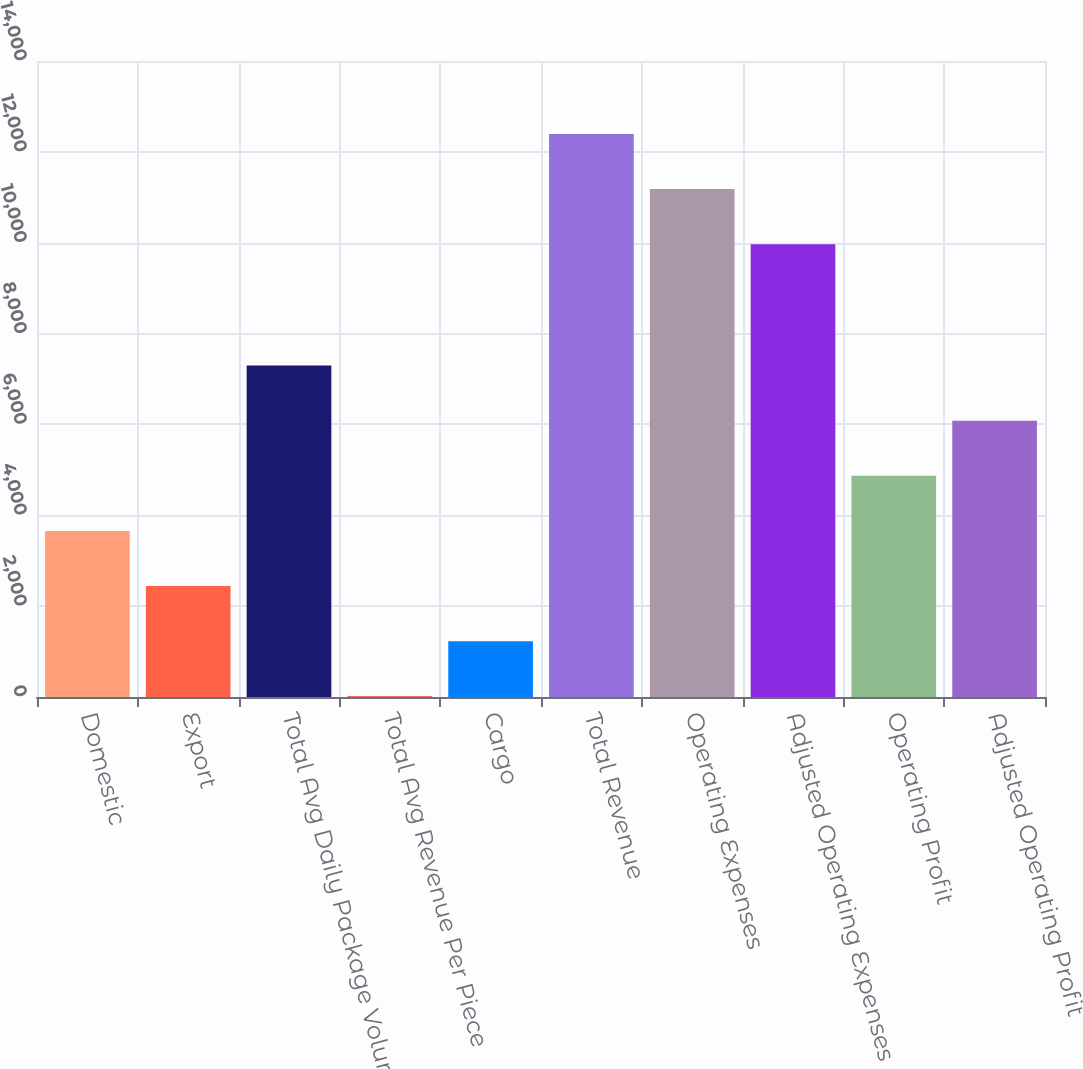Convert chart to OTSL. <chart><loc_0><loc_0><loc_500><loc_500><bar_chart><fcel>Domestic<fcel>Export<fcel>Total Avg Daily Package Volume<fcel>Total Avg Revenue Per Piece<fcel>Cargo<fcel>Total Revenue<fcel>Operating Expenses<fcel>Adjusted Operating Expenses<fcel>Operating Profit<fcel>Adjusted Operating Profit<nl><fcel>3656.35<fcel>2443.11<fcel>7296.07<fcel>16.63<fcel>1229.87<fcel>12394.5<fcel>11181.2<fcel>9968<fcel>4869.59<fcel>6082.83<nl></chart> 